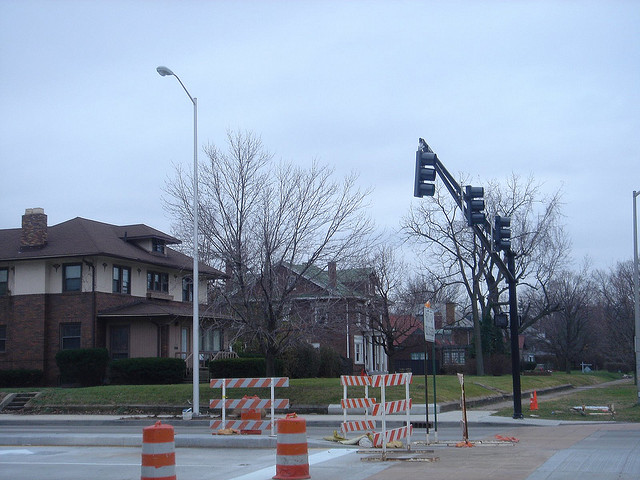<image>How is traffic at this intersection? It's ambiguous to determine how the traffic is at this intersection. It could be clear, blocked, light, or even nonexistent. How is traffic at this intersection? I don't know how is traffic at this intersection. It can be seen as light or blocked. 